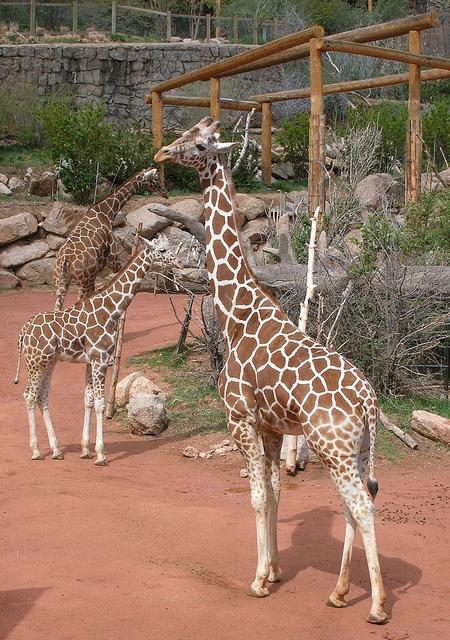How many animals?
Write a very short answer. 3. How many posts?
Short answer required. 5. What animal is this?
Concise answer only. Giraffe. 